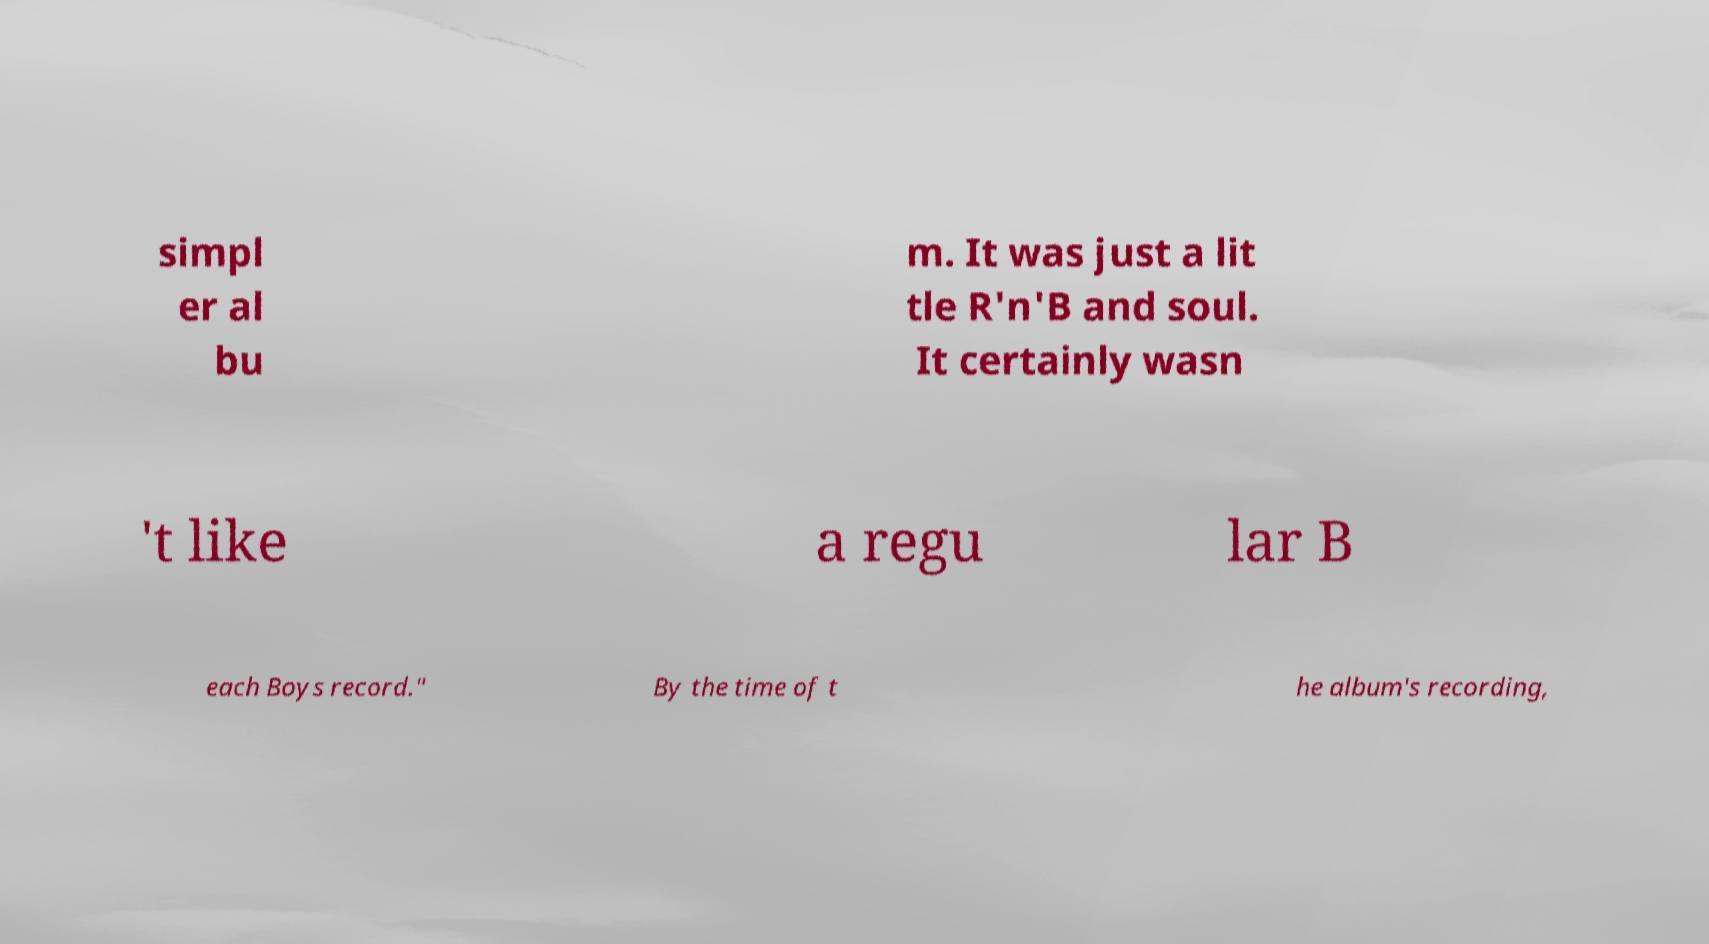Please read and relay the text visible in this image. What does it say? simpl er al bu m. It was just a lit tle R'n'B and soul. It certainly wasn 't like a regu lar B each Boys record." By the time of t he album's recording, 